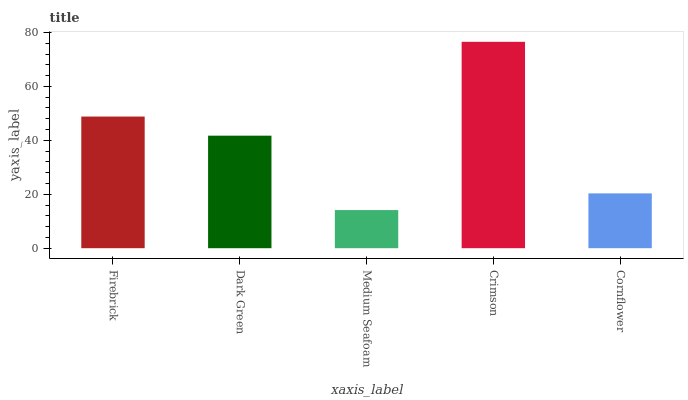Is Dark Green the minimum?
Answer yes or no. No. Is Dark Green the maximum?
Answer yes or no. No. Is Firebrick greater than Dark Green?
Answer yes or no. Yes. Is Dark Green less than Firebrick?
Answer yes or no. Yes. Is Dark Green greater than Firebrick?
Answer yes or no. No. Is Firebrick less than Dark Green?
Answer yes or no. No. Is Dark Green the high median?
Answer yes or no. Yes. Is Dark Green the low median?
Answer yes or no. Yes. Is Medium Seafoam the high median?
Answer yes or no. No. Is Crimson the low median?
Answer yes or no. No. 